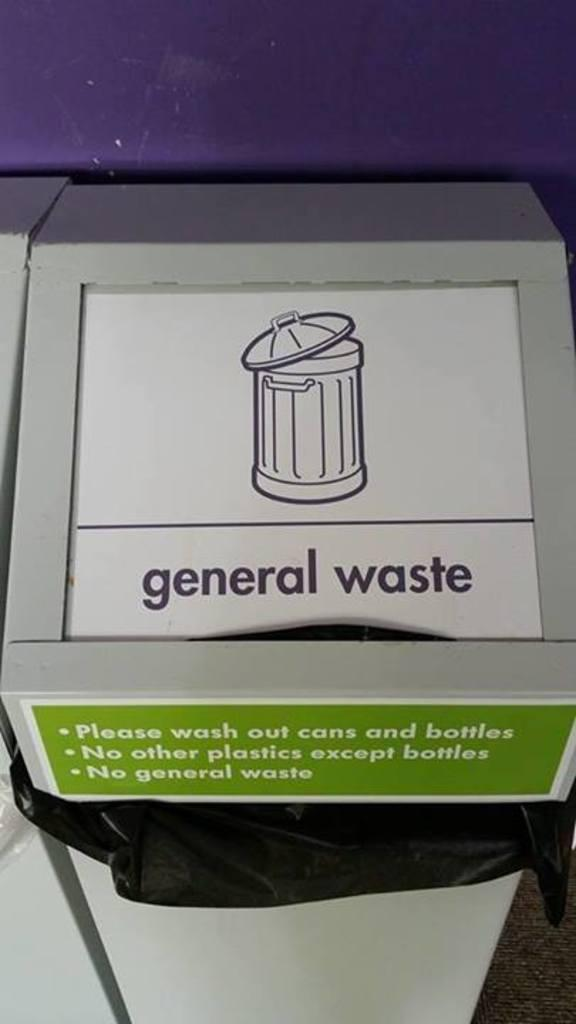<image>
Create a compact narrative representing the image presented. A white trash bin labelled General waste for bottles. 